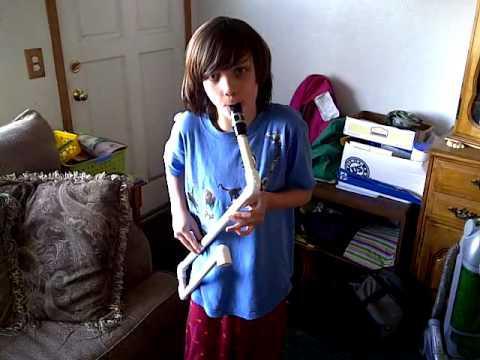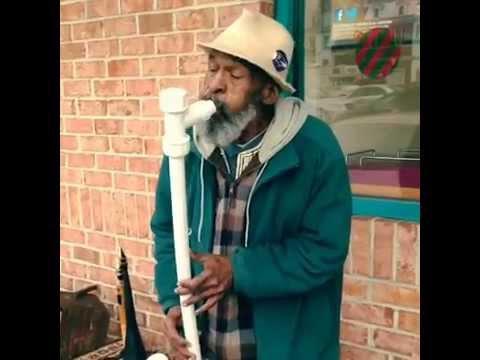The first image is the image on the left, the second image is the image on the right. Analyze the images presented: Is the assertion "Two people can be seen holding a musical instrument." valid? Answer yes or no. Yes. The first image is the image on the left, the second image is the image on the right. Given the left and right images, does the statement "Someone is playing an instrument." hold true? Answer yes or no. Yes. 